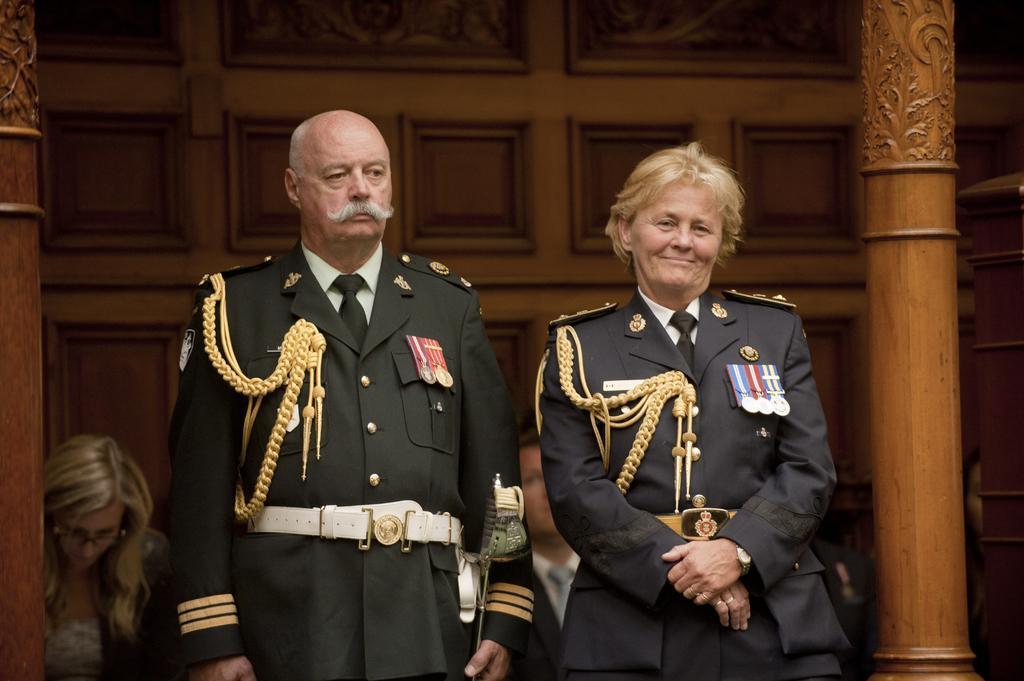Could you give a brief overview of what you see in this image? In this image I can see people where few are standing and few are sitting. I can also see few are wearing uniforms and here I can see smile on her face. 